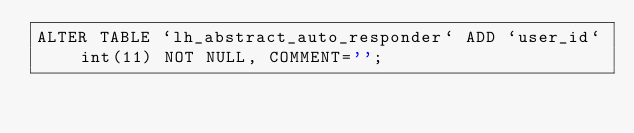<code> <loc_0><loc_0><loc_500><loc_500><_SQL_>ALTER TABLE `lh_abstract_auto_responder` ADD `user_id` int(11) NOT NULL, COMMENT='';</code> 